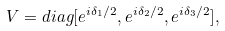<formula> <loc_0><loc_0><loc_500><loc_500>V = d i a g [ e ^ { i \delta _ { 1 } / 2 } , e ^ { i \delta _ { 2 } / 2 } , e ^ { i \delta _ { 3 } / 2 } ] ,</formula> 